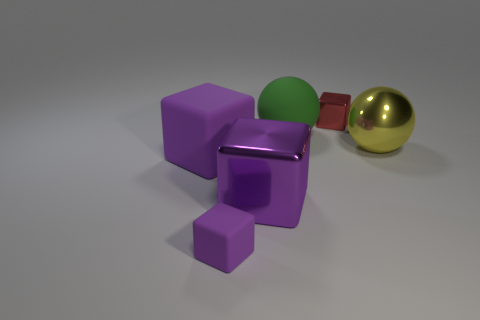There is a large purple object that is made of the same material as the large green thing; what is its shape?
Your answer should be compact. Cube. Does the tiny rubber block have the same color as the big rubber cube?
Provide a succinct answer. Yes. Are the tiny thing in front of the big matte cube and the ball that is on the left side of the red cube made of the same material?
Keep it short and to the point. Yes. How many things are either small green things or tiny things right of the small purple rubber cube?
Your answer should be compact. 1. What is the big green thing made of?
Your answer should be very brief. Rubber. Do the large green object and the small purple block have the same material?
Offer a very short reply. Yes. How many metal objects are red cubes or balls?
Provide a short and direct response. 2. The small object that is behind the yellow sphere has what shape?
Ensure brevity in your answer.  Cube. There is a sphere that is made of the same material as the small red object; what is its size?
Your answer should be compact. Large. There is a matte object that is behind the tiny purple rubber thing and to the right of the large rubber block; what is its shape?
Ensure brevity in your answer.  Sphere. 